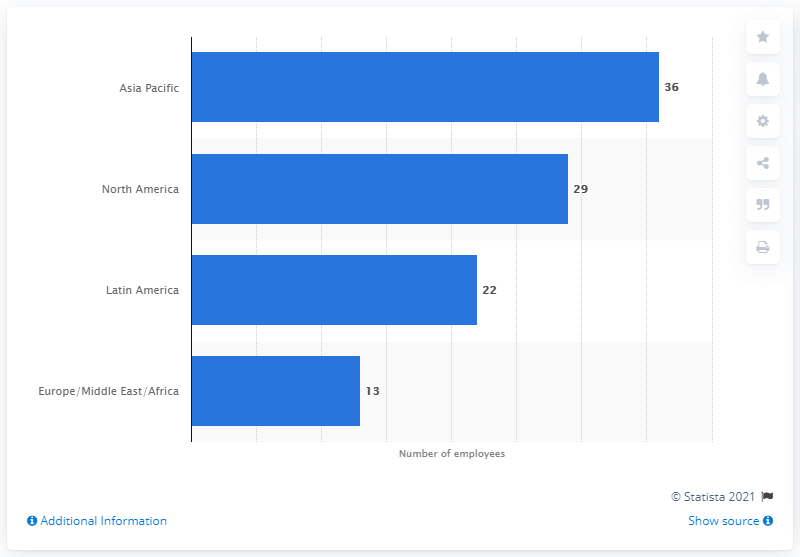Identify some key points in this picture. Cargill employs a significant percentage of Latin American workers, with 22% of its workforce hailing from this region. 